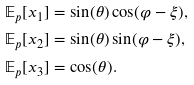Convert formula to latex. <formula><loc_0><loc_0><loc_500><loc_500>\mathbb { E } _ { p } [ x _ { 1 } ] & = \sin ( \theta ) \cos ( \varphi - \xi ) , \\ \mathbb { E } _ { p } [ x _ { 2 } ] & = \sin ( \theta ) \sin ( \varphi - \xi ) , \\ \mathbb { E } _ { p } [ x _ { 3 } ] & = \cos ( \theta ) .</formula> 